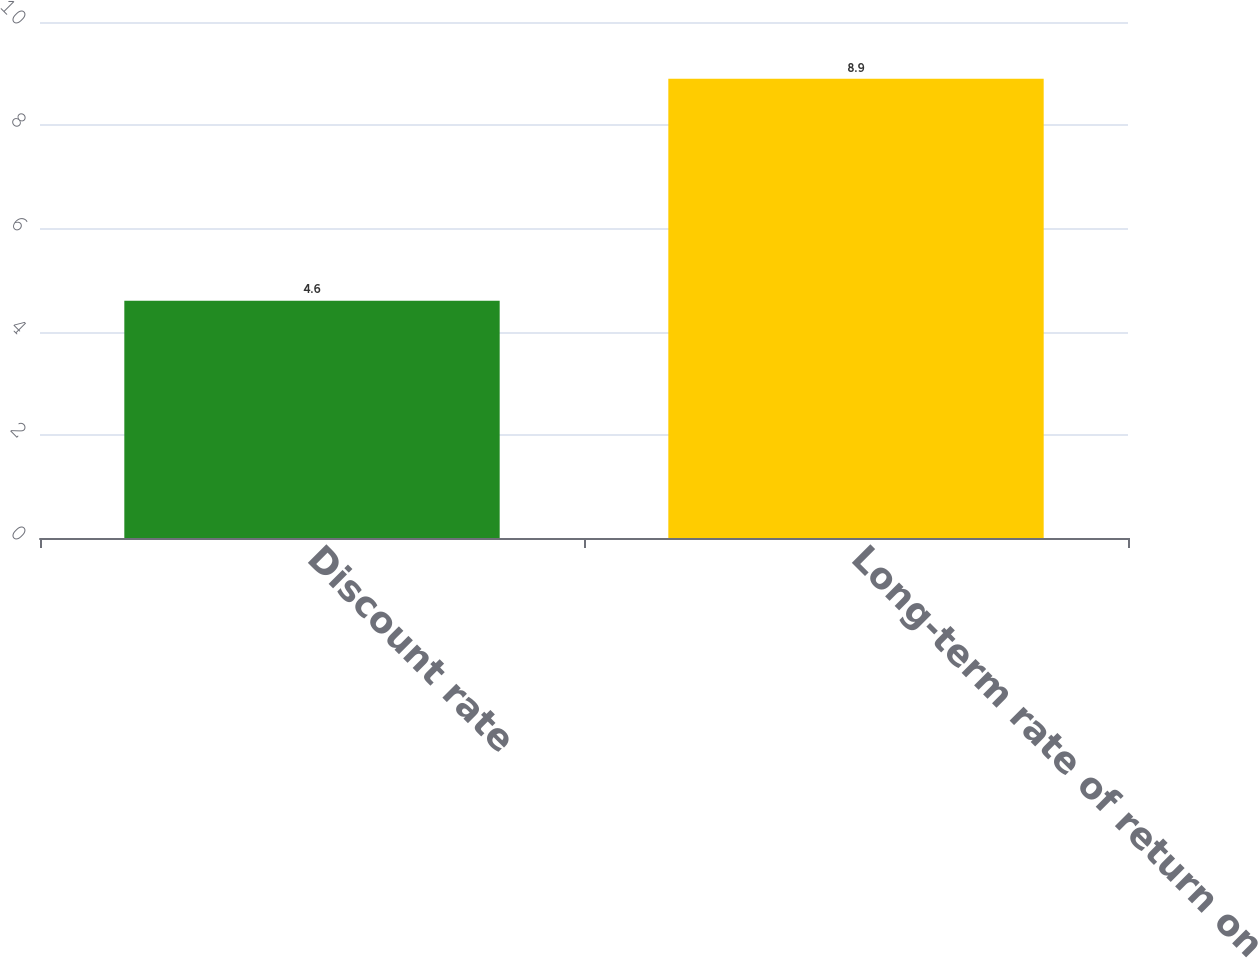Convert chart. <chart><loc_0><loc_0><loc_500><loc_500><bar_chart><fcel>Discount rate<fcel>Long-term rate of return on<nl><fcel>4.6<fcel>8.9<nl></chart> 